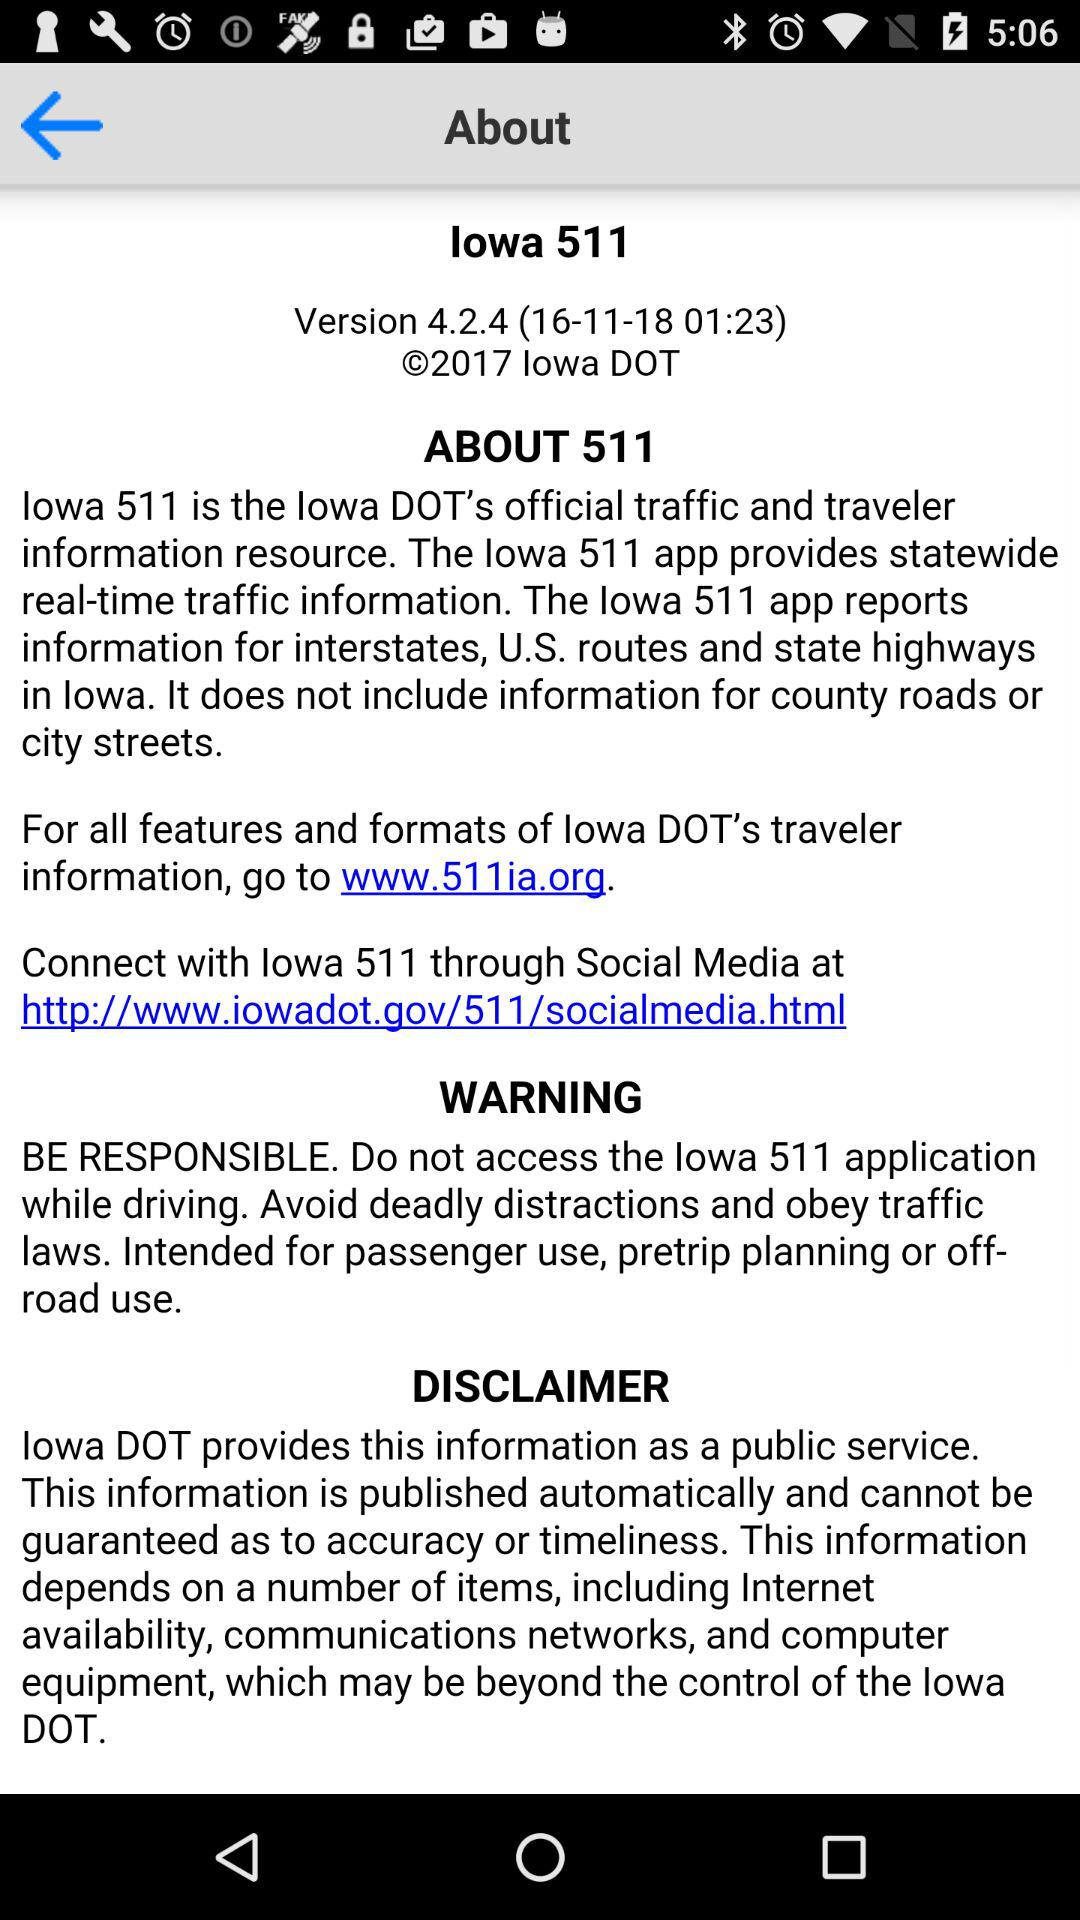What is the link address I can use to "Connect with lowa 511 through Social Media"? The link address is http://www.iowadot.gov/511/socialmedia.html. 